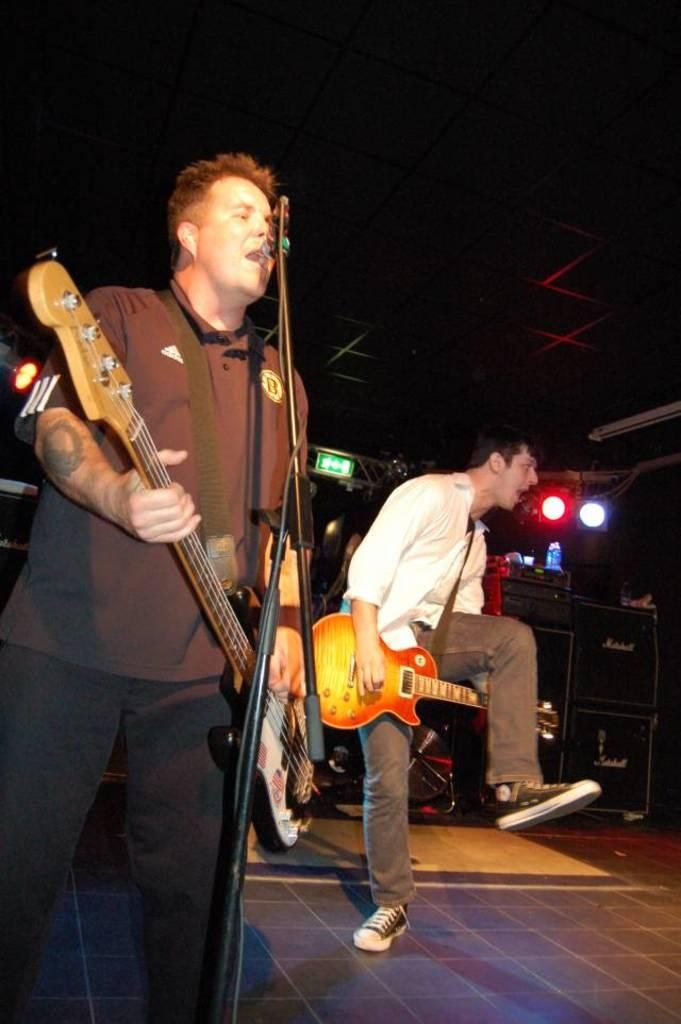How many people are in the image? There are two persons in the image. What are the two persons doing in the image? The two persons are playing musical instruments. What type of leather material can be seen on the calendar in the image? There is no calendar or leather material present in the image. 